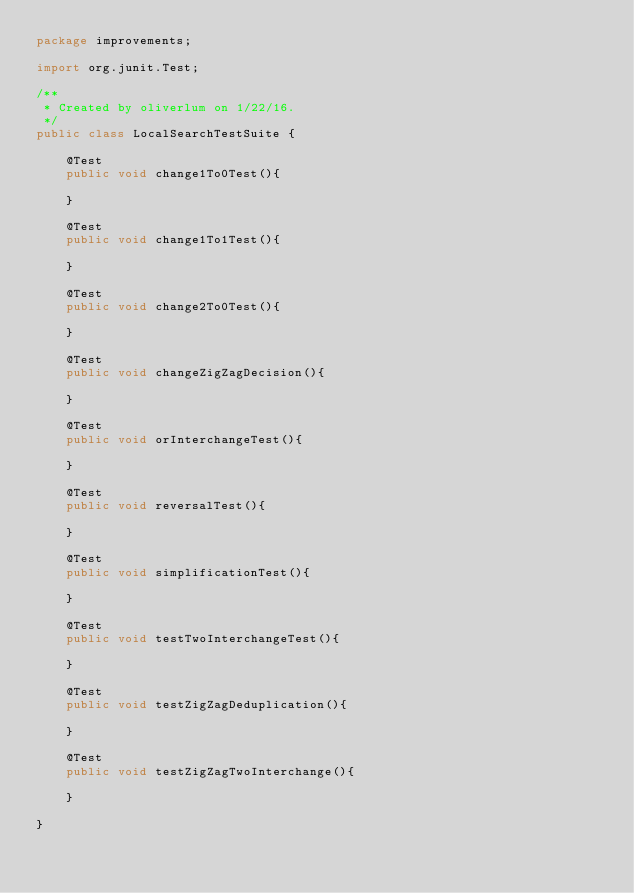<code> <loc_0><loc_0><loc_500><loc_500><_Java_>package improvements;

import org.junit.Test;

/**
 * Created by oliverlum on 1/22/16.
 */
public class LocalSearchTestSuite {

    @Test
    public void change1To0Test(){

    }

    @Test
    public void change1To1Test(){

    }

    @Test
    public void change2To0Test(){

    }

    @Test
    public void changeZigZagDecision(){

    }

    @Test
    public void orInterchangeTest(){

    }

    @Test
    public void reversalTest(){

    }

    @Test
    public void simplificationTest(){

    }

    @Test
    public void testTwoInterchangeTest(){

    }

    @Test
    public void testZigZagDeduplication(){

    }

    @Test
    public void testZigZagTwoInterchange(){

    }

}
</code> 